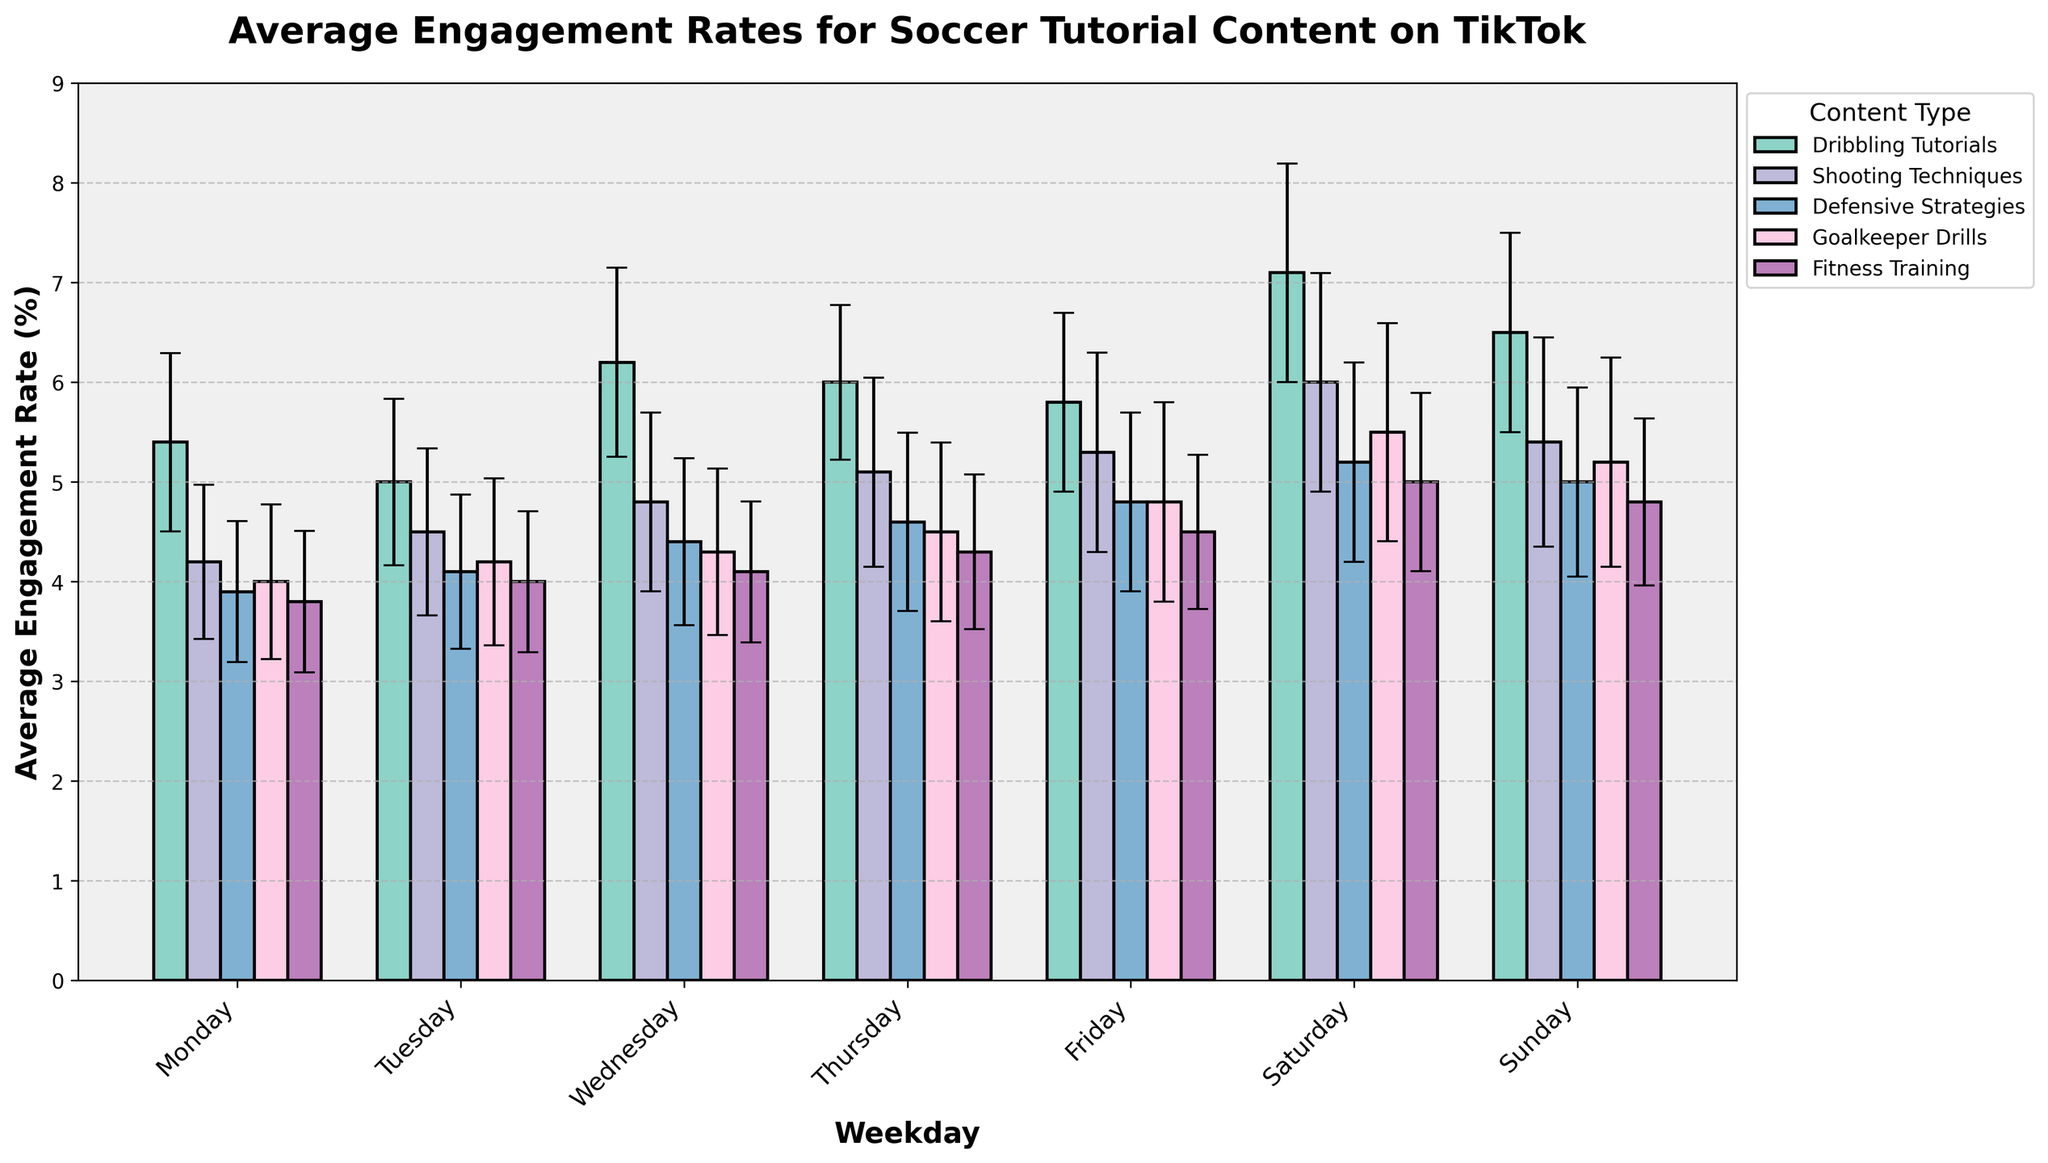What is the title of the bar chart? The title is typically found at the top of the chart and summarizes what the chart is about.
Answer: Average Engagement Rates for Soccer Tutorial Content on TikTok Which content type has the highest average engagement rate on Saturday? Identify the bar corresponding to Saturday for each content type and find the one with the highest value.
Answer: Dribbling Tutorials Which day of the week has the lowest average engagement rate for Fitness Training content? Look at the bars for Fitness Training and identify the one with the lowest height, which corresponds to the average engagement rate on that day.
Answer: Monday By how much does the average engagement rate for Dribbling Tutorials on Saturday exceed the rate on Monday? Compare the height of the bars for Dribbling Tutorials on Saturday and Monday and calculate the difference.
Answer: 1.7 Do Shooting Techniques videos have higher engagement rates on weekends (Saturday and Sunday) compared to weekdays (Monday to Friday)? Add the average engagement rates for Shooting Techniques on Saturday and Sunday, then compare this sum to the total sum of the average engagement rates from Monday to Friday.
Answer: Yes Which content type shows the greatest variance in the engagement rate across all days of the week? Compare the error bars for each content type across all days of the week and identify the one with the largest average variance.
Answer: Dribbling Tutorials What is the average engagement rate for Goalkeeper Drills content on weekdays (Monday to Friday)? Sum up the average engagement rates for Goalkeeper Drills from Monday to Friday and divide by the number of days.
Answer: 4.36 Which content type shows the least fluctuation in their engagement rates throughout the week? Look at the error bars and the spread of the average engagement rates across the week for each content type, identifying the one with the smallest fluctuations.
Answer: Fitness Training On which day is the engagement rate for Defensive Strategies content the highest? Identify the day where the bar for Defensive Strategies is tallest.
Answer: Saturday What is the range of average engagement rates for Shooting Techniques content across the week? Find the difference between the highest and lowest average engagement rate for Shooting Techniques content.
Answer: 1.8 